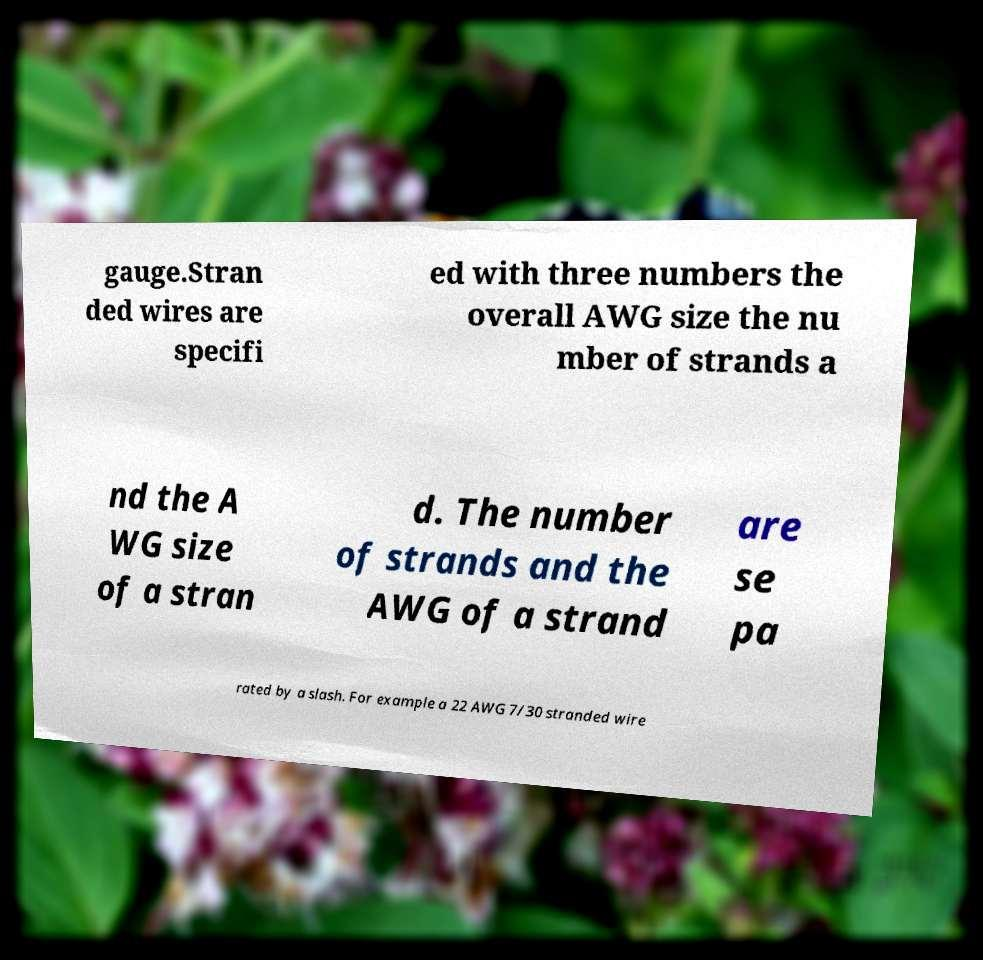There's text embedded in this image that I need extracted. Can you transcribe it verbatim? gauge.Stran ded wires are specifi ed with three numbers the overall AWG size the nu mber of strands a nd the A WG size of a stran d. The number of strands and the AWG of a strand are se pa rated by a slash. For example a 22 AWG 7/30 stranded wire 